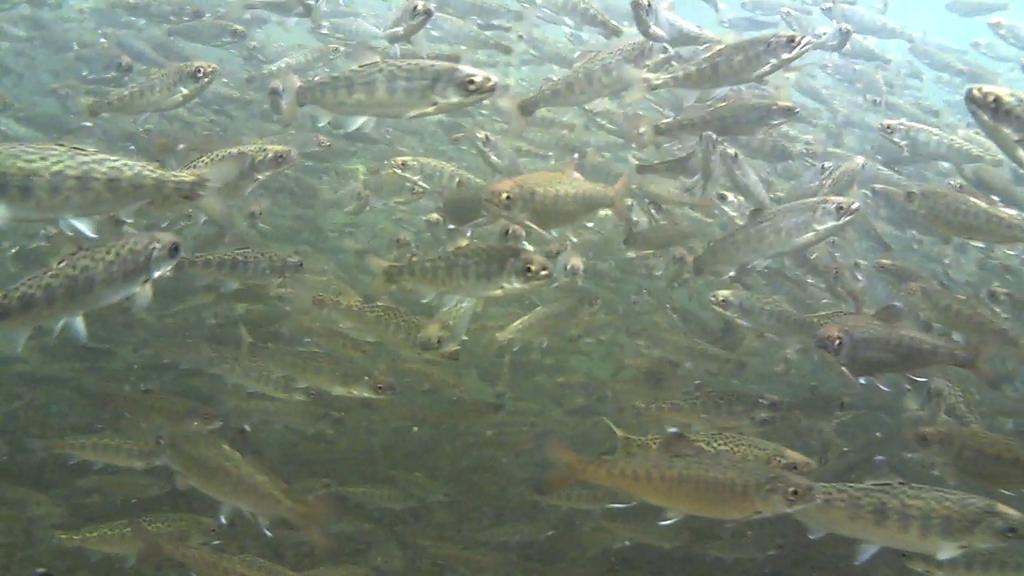What type of animals are in the image? There are fishes in the image. Where are the fishes located? The fishes are in the water. What type of plant is being driven by the aunt in the image? There is no plant or aunt present in the image; it features fishes in the water. 